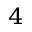<formula> <loc_0><loc_0><loc_500><loc_500>^ { 4 }</formula> 